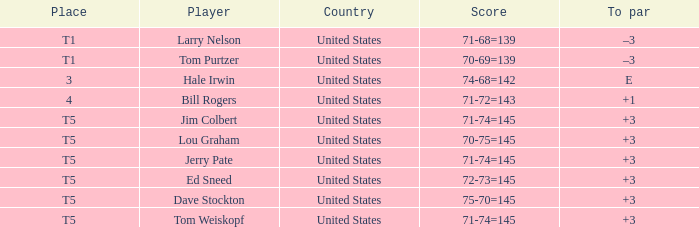Which country is the golfer ed sneed, having a to par of +3, a native of? United States. 